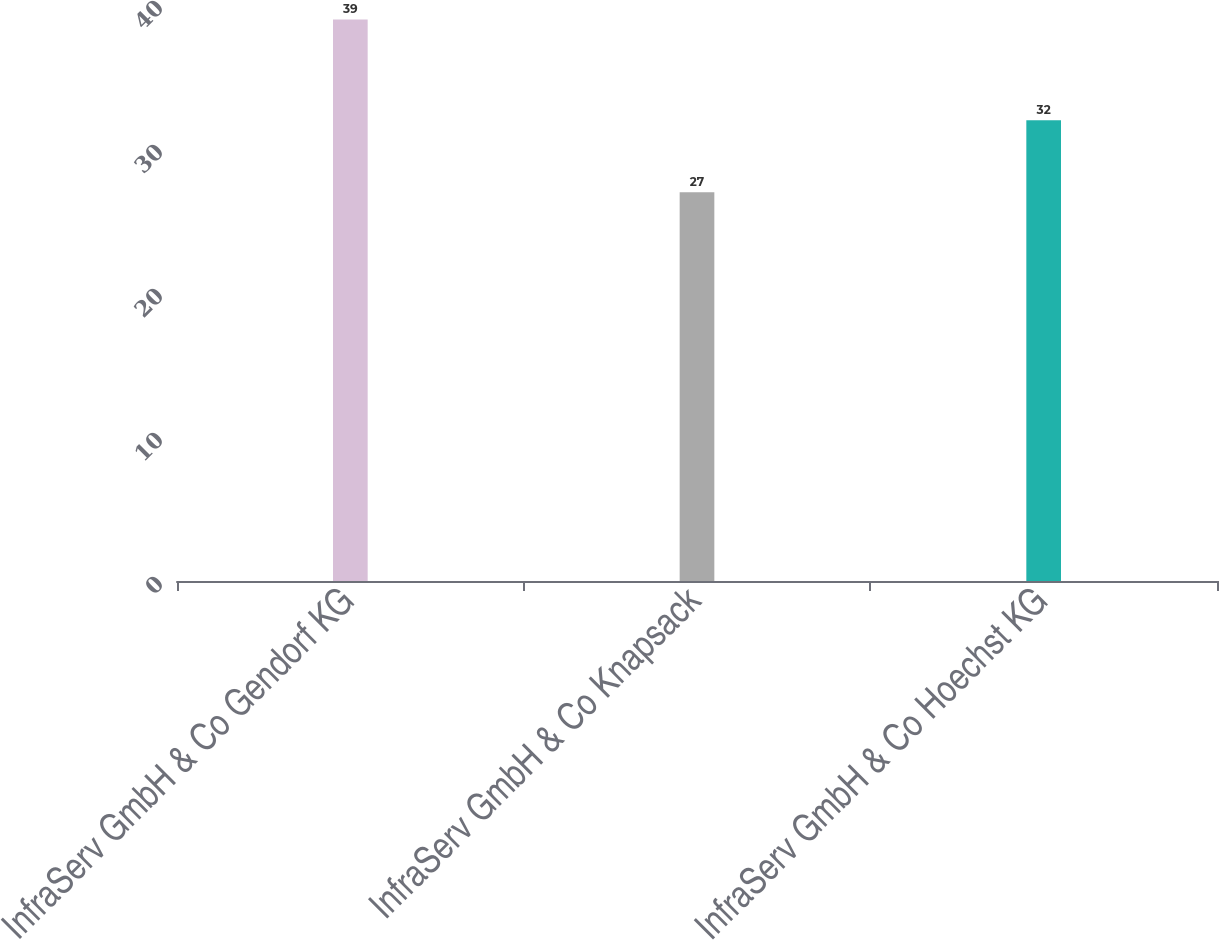Convert chart. <chart><loc_0><loc_0><loc_500><loc_500><bar_chart><fcel>InfraServ GmbH & Co Gendorf KG<fcel>InfraServ GmbH & Co Knapsack<fcel>InfraServ GmbH & Co Hoechst KG<nl><fcel>39<fcel>27<fcel>32<nl></chart> 